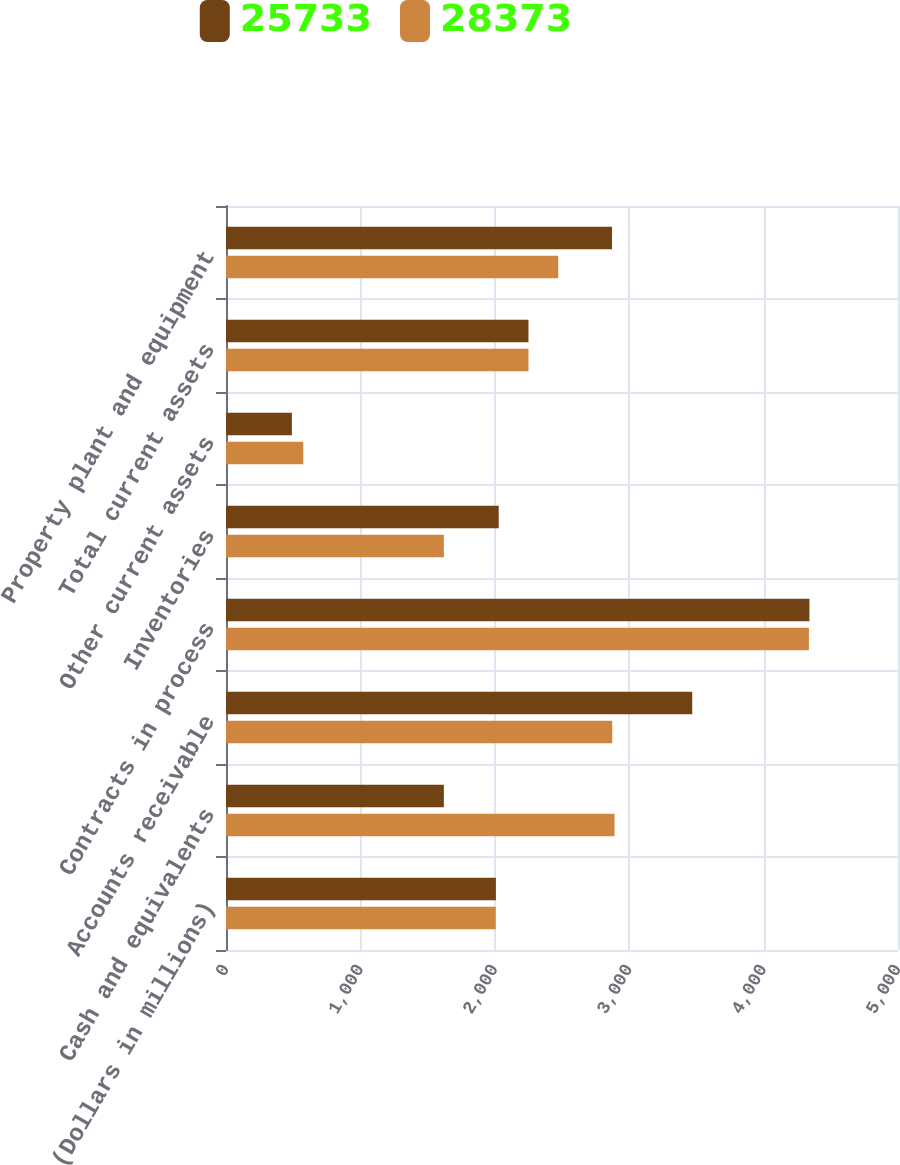Convert chart. <chart><loc_0><loc_0><loc_500><loc_500><stacked_bar_chart><ecel><fcel>(Dollars in millions)<fcel>Cash and equivalents<fcel>Accounts receivable<fcel>Contracts in process<fcel>Inventories<fcel>Other current assets<fcel>Total current assets<fcel>Property plant and equipment<nl><fcel>25733<fcel>2008<fcel>1621<fcel>3469<fcel>4341<fcel>2029<fcel>490<fcel>2250.5<fcel>2872<nl><fcel>28373<fcel>2007<fcel>2891<fcel>2874<fcel>4337<fcel>1621<fcel>575<fcel>2250.5<fcel>2472<nl></chart> 